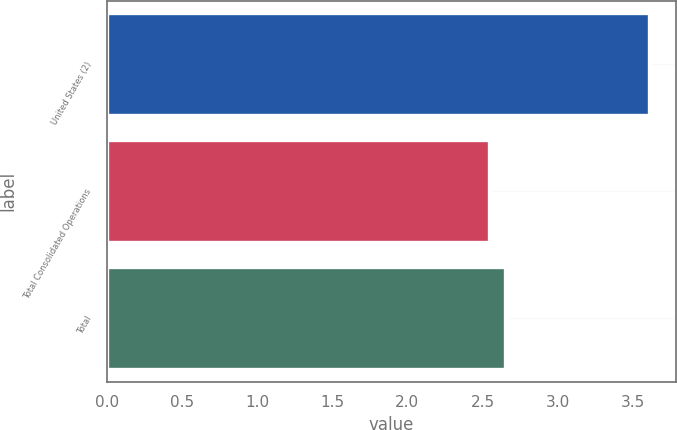<chart> <loc_0><loc_0><loc_500><loc_500><bar_chart><fcel>United States (2)<fcel>Total Consolidated Operations<fcel>Total<nl><fcel>3.61<fcel>2.54<fcel>2.65<nl></chart> 